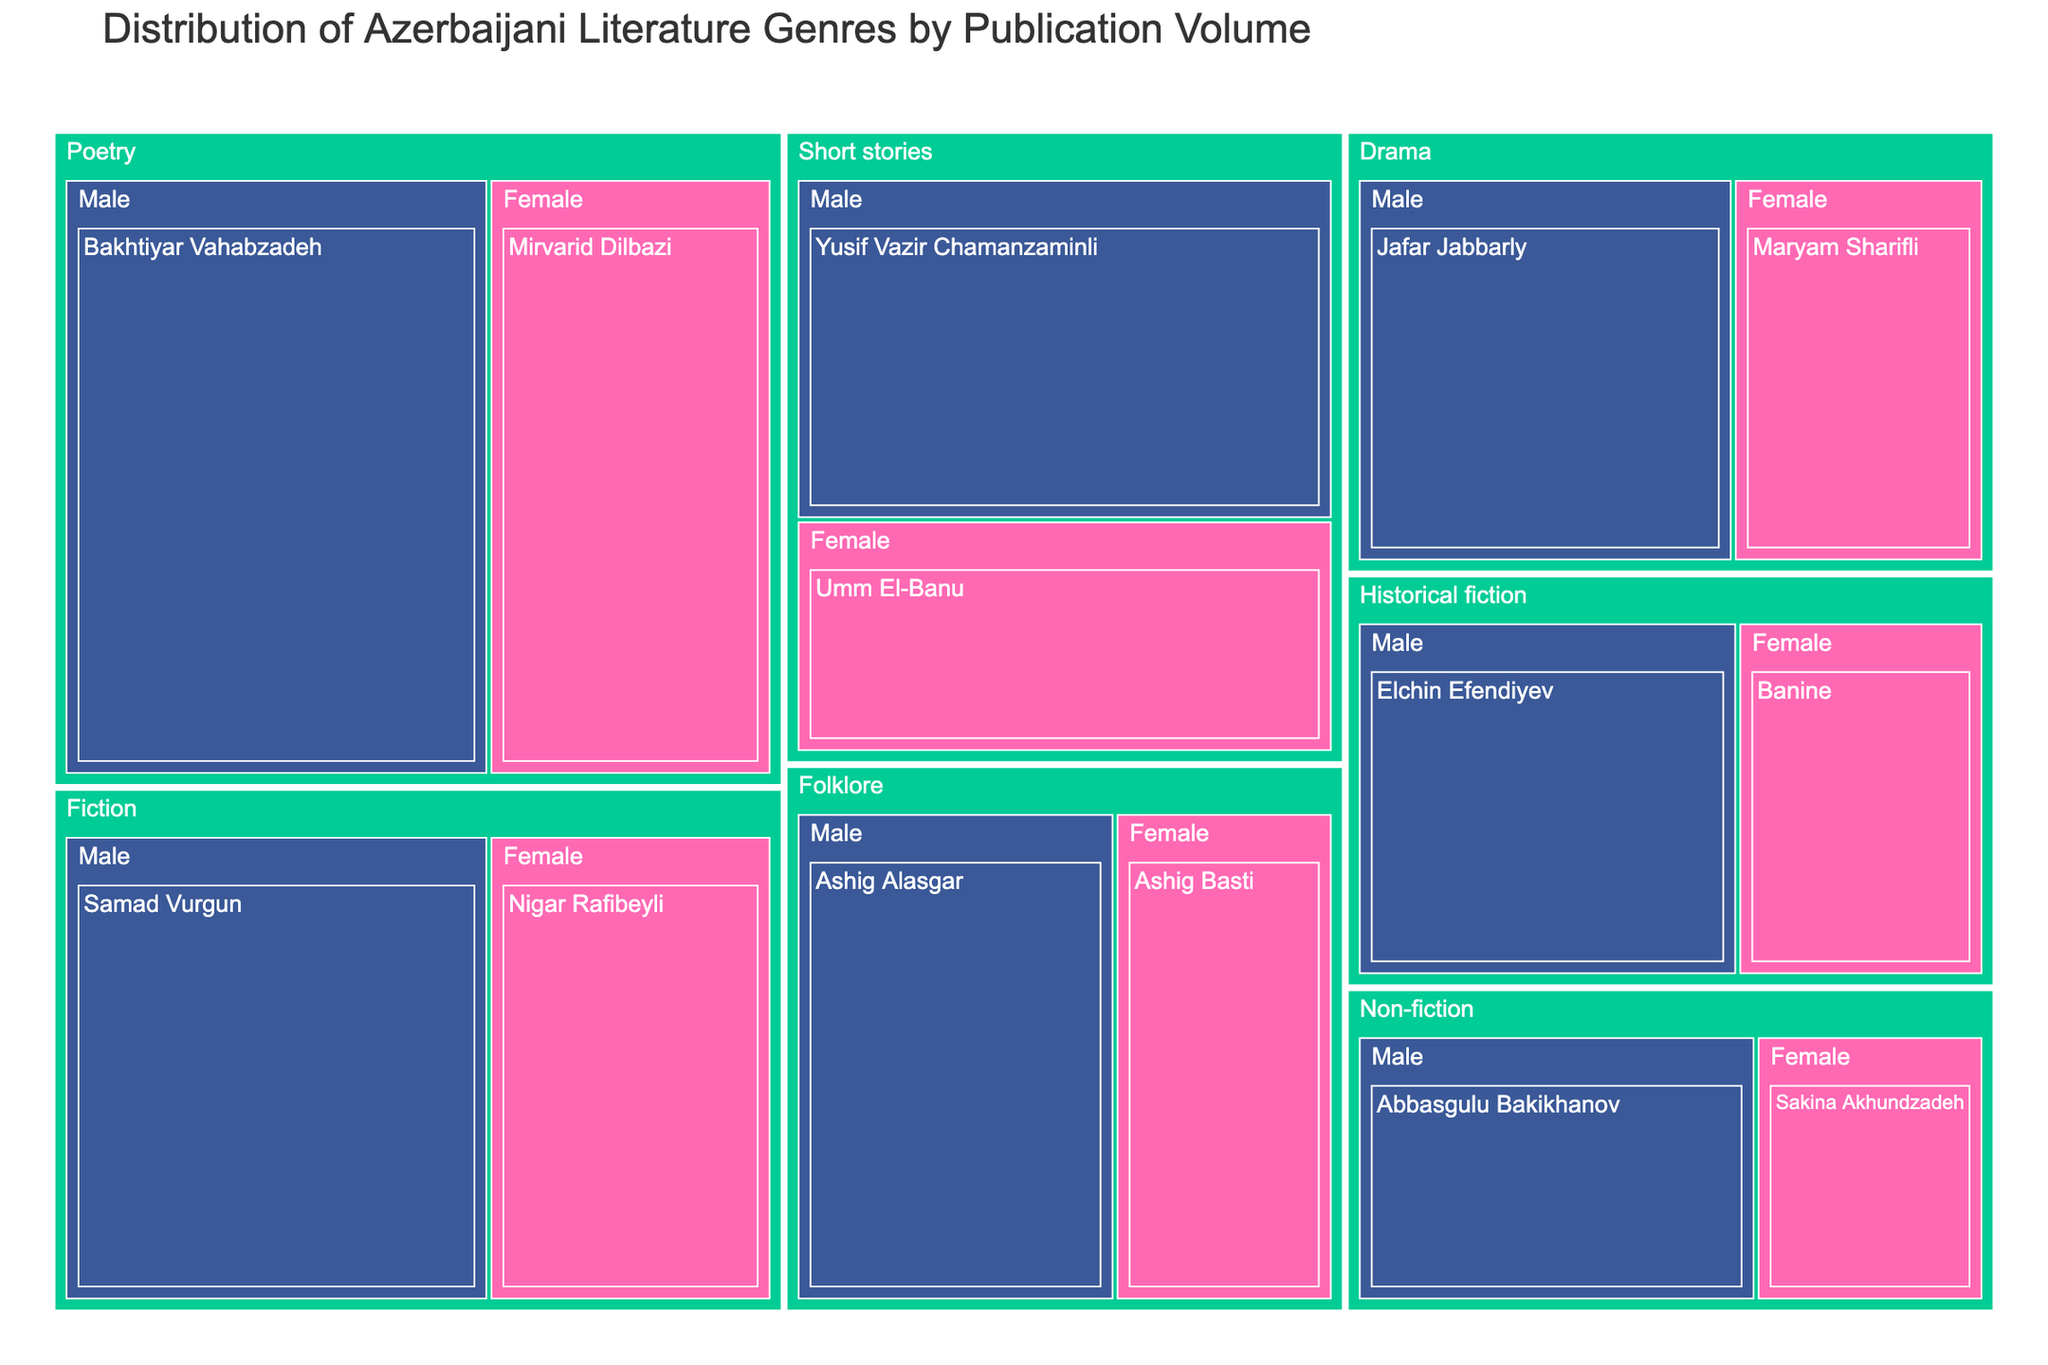What is the total number of publications in the Fiction genre? Look at all the publications values under the Fiction genre for both male and female authors. Sum them up: 120 (Samad Vurgun) + 80 (Nigar Rafibeyli) = 200
Answer: 200 How many publications are authored by male writers in the Drama genre? Look at the publications value under the Drama genre written by the male author, Jafar Jabbarly. The value is 90.
Answer: 90 What is the difference in the number of publications between male and female authors in Non-fiction? Find the publications of male and female authors in Non-fiction and subtract them. Abbasgulu Bakikhanov (70) - Sakina Akhundzadeh (40) = 30.
Answer: 30 Which gender has a higher number of total publications in Historical fiction, and by how much? Find the total number of publications by male and female authors in Historical fiction. Male: 85 (Elchin Efendiyev), Female: 55 (Banine). The difference is 85 - 55 = 30.
Answer: Male by 30 Compare the number of publications by Mirvarid Dilbazi and Nigar Rafibeyli. Who has more publications? Look up the values for Mirvarid Dilbazi (100) and Nigar Rafibeyli (80). Compare the two numbers. Mirvarid Dilbazi has more.
Answer: Mirvarid Dilbazi In which genre is the difference in publication volumes between male and female authors the smallest? Calculate the differences for each genre: Fiction: 40, Poetry: 50, Drama: 30, Non-fiction: 30, Short stories: 35, Historical fiction: 30, Folklore: 30. The smallest difference appears in Fiction with 40.
Answer: Drama, Non-fiction, Historical fiction, and Folklore all have the smallest difference of 30 What is the overall number of publications by female authors across all genres? Sum the publications of all female authors across genres: 80 (Fiction) + 100 (Poetry) + 60 (Drama) + 40 (Non-fiction) + 75 (Short stories) + 55 (Historical fiction) + 65 (Folklore) = 475.
Answer: 475 